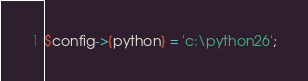Convert code to text. <code><loc_0><loc_0><loc_500><loc_500><_SQL_>$config->{python} = 'c:\python26';
</code> 